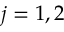<formula> <loc_0><loc_0><loc_500><loc_500>j = 1 , 2</formula> 